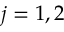<formula> <loc_0><loc_0><loc_500><loc_500>j = 1 , 2</formula> 